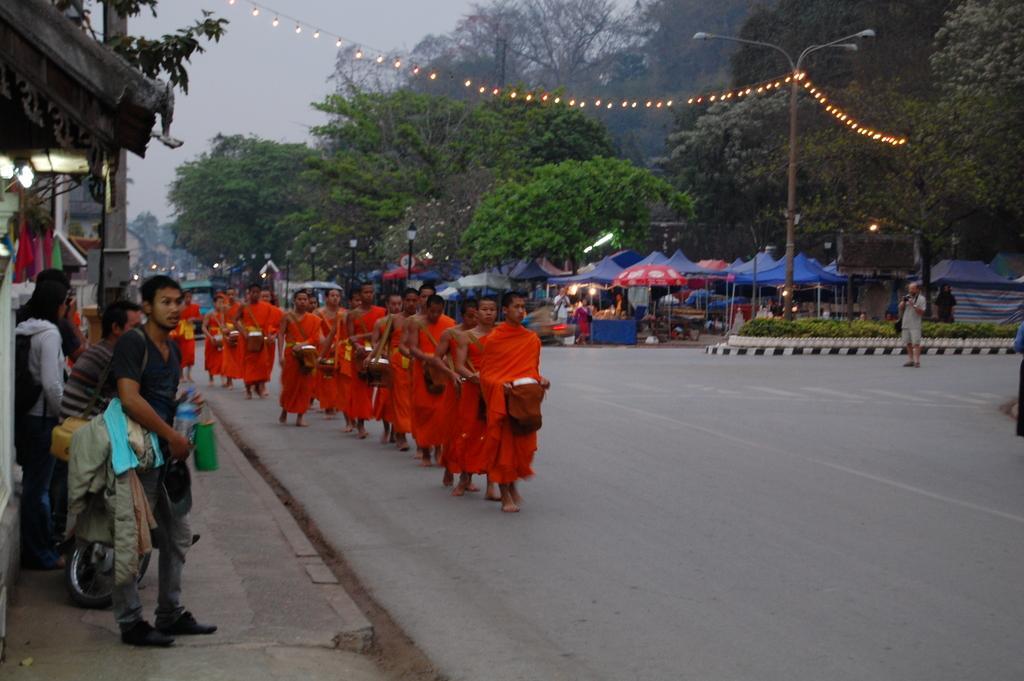Can you describe this image briefly? In the picture I can see people among them some are walking on the road and holding some objects in hands. These people are wearing orange color clothes. I can see trees, street lights, string lights, plants, stalls and some other objects. In the background I can see the sky. 